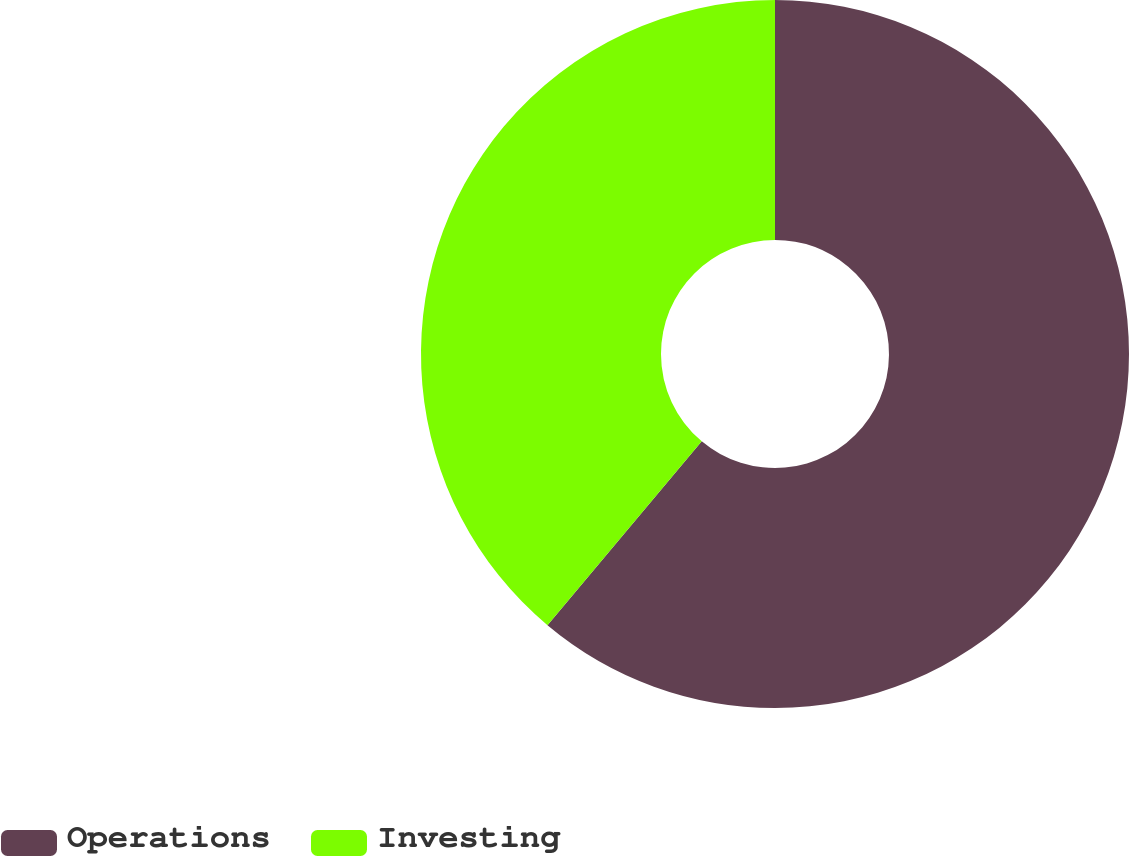Convert chart. <chart><loc_0><loc_0><loc_500><loc_500><pie_chart><fcel>Operations<fcel>Investing<nl><fcel>61.11%<fcel>38.89%<nl></chart> 